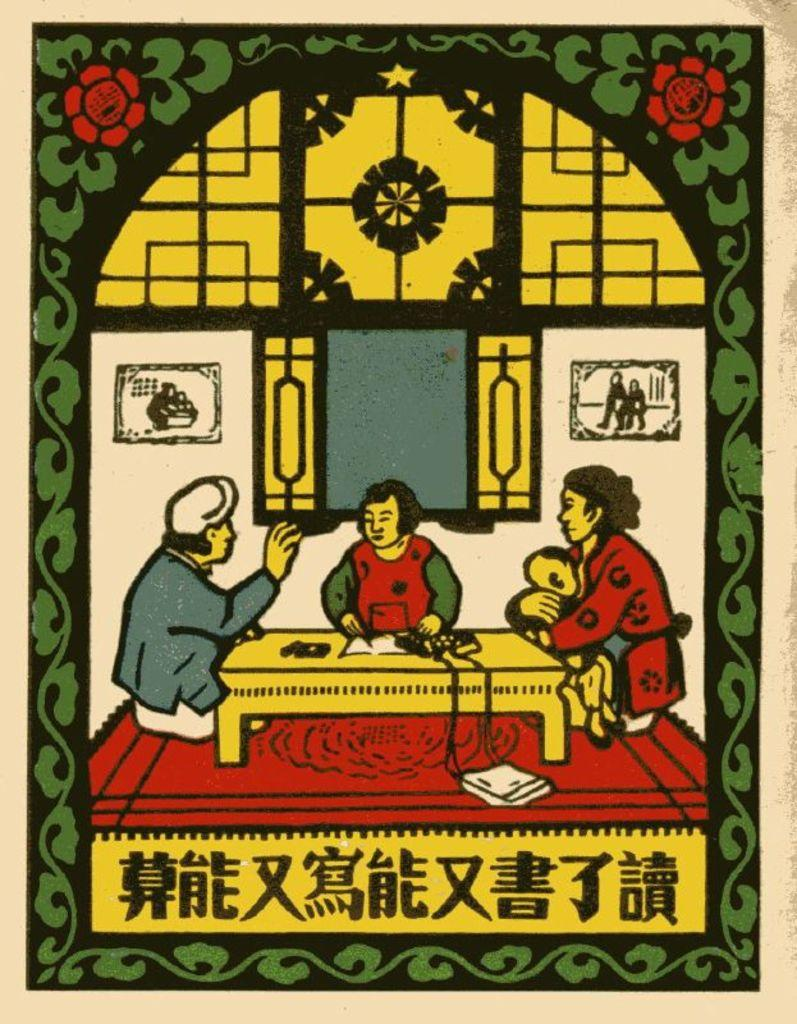What is the main feature of the image? There is a logo printed in the image. What are the people in the image doing? The people are sitting on the floor in the image. What piece of furniture is present in the image? There is a table in the image. What type of instrument can be seen in the image? There is no instrument present in the image. 